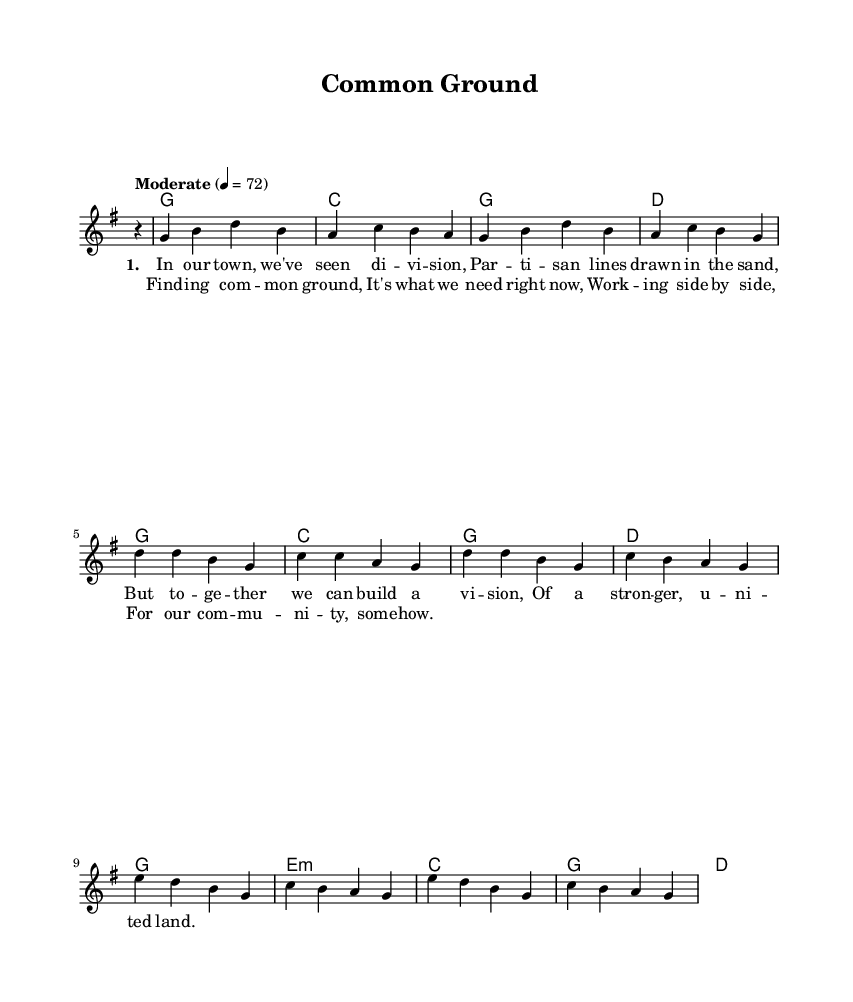What is the key signature of this music? The key signature is indicated at the beginning of the score, showing one sharp, which corresponds to the key of G major.
Answer: G major What is the time signature of this music? The time signature is displayed at the start of the score, indicating there are four beats per measure. This is denoted as 4/4.
Answer: 4/4 What is the tempo marking for this piece? The tempo marking is shown above the staff and indicates a moderate pace, specifically with a metronome marking of 72 beats per minute.
Answer: Moderate 4 = 72 What are the first lyrics of the verse? The verse lyrics begin the lyrical section in the score, and the first line is "In our town, we've seen di -- vi -- sion".
Answer: In our town, we've seen di -- vi -- sion How many chords are there in the chorus? The number of unique chord symbols within the chorus section can be counted, and since there are four distinct chords, the total is four.
Answer: 4 What is the emotional theme of the lyrics? The lyrics express unity and collaboration in the face of division, emphasizing a need for cooperation in a community context.
Answer: Unity What musical form does this song represent? The structure of the song includes verses followed by a chorus, typical of country songs which often focus on storytelling and emotional reflection.
Answer: Verse-Chorus form 